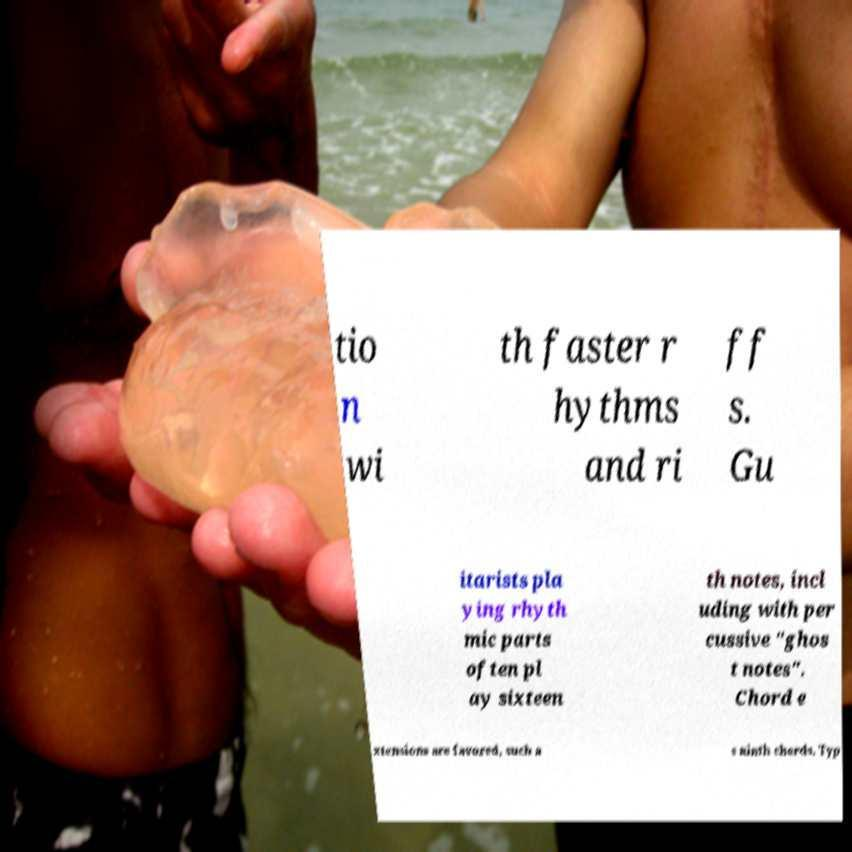Please identify and transcribe the text found in this image. tio n wi th faster r hythms and ri ff s. Gu itarists pla ying rhyth mic parts often pl ay sixteen th notes, incl uding with per cussive "ghos t notes". Chord e xtensions are favored, such a s ninth chords. Typ 